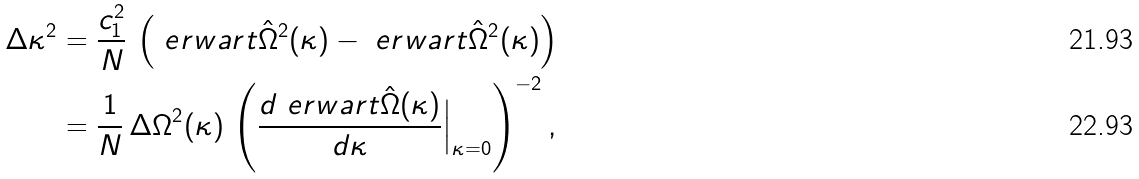Convert formula to latex. <formula><loc_0><loc_0><loc_500><loc_500>\Delta \kappa ^ { 2 } & = \frac { c _ { 1 } ^ { 2 } } { N } \, \left ( \ e r w a r t { \hat { \Omega } ^ { 2 } } ( \kappa ) - \ e r w a r t { \hat { \Omega } } ^ { 2 } ( \kappa ) \right ) \\ & = \frac { 1 } { N } \, \Delta \Omega ^ { 2 } ( \kappa ) \, \left ( \frac { d \ e r w a r t { \hat { \Omega } } ( \kappa ) } { d \kappa } \Big | _ { \kappa = 0 } \right ) ^ { - 2 } ,</formula> 